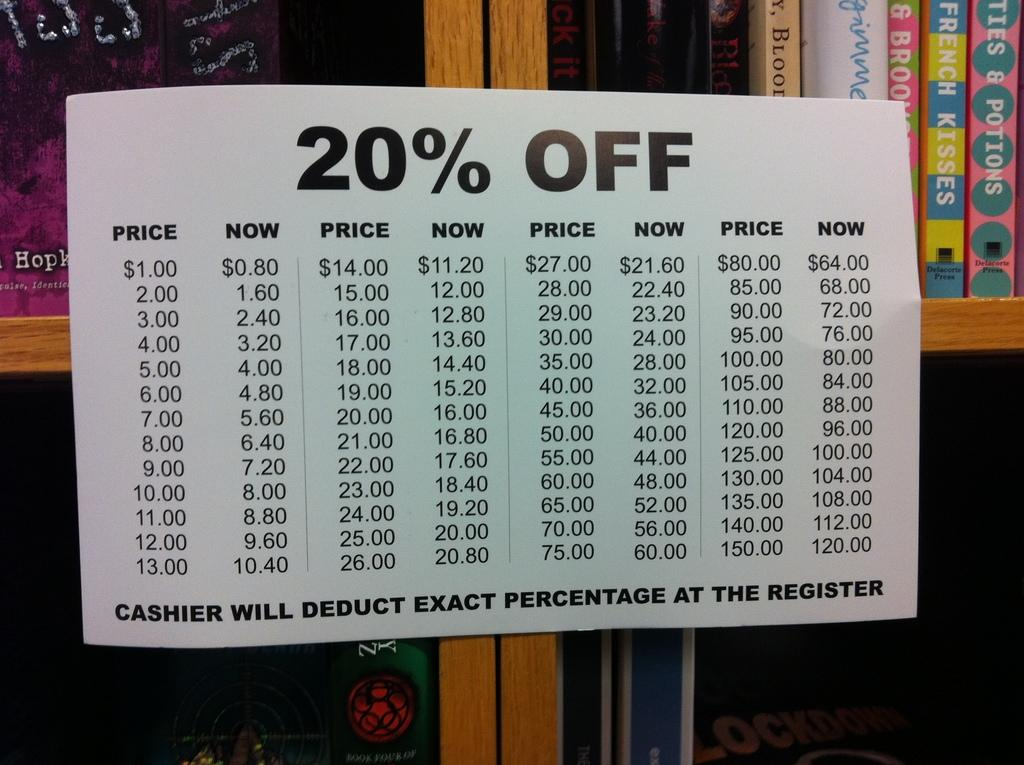<image>
Create a compact narrative representing the image presented. A sign taped to a bookshelf shows prices after a 20% deduction has been calculated. 